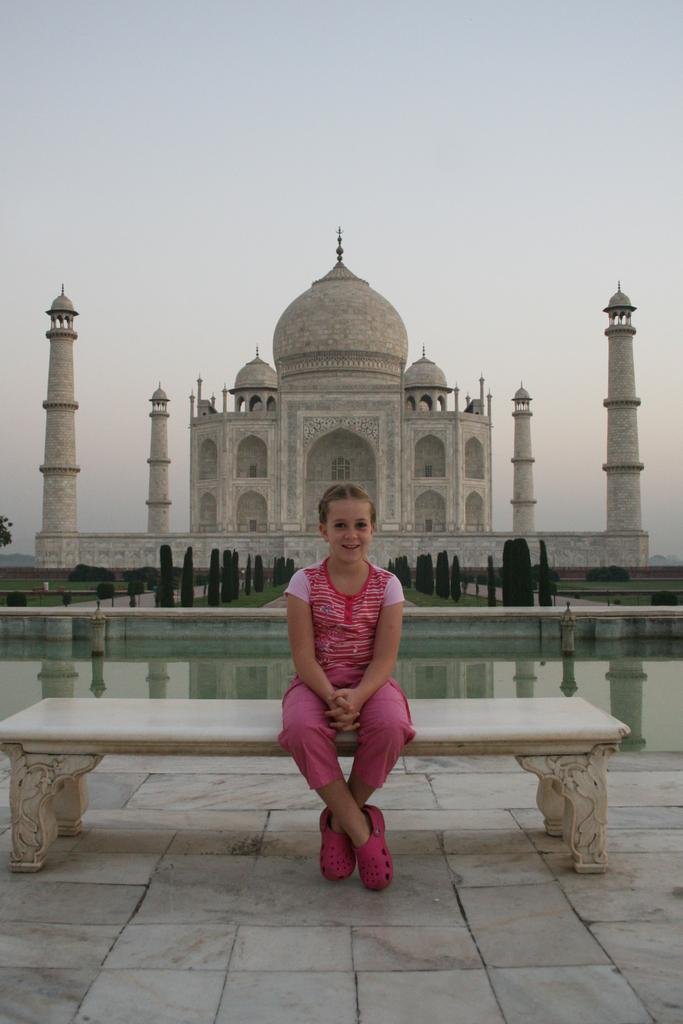Who is the main subject in the image? There is a girl in the image. What is the girl wearing? The girl is wearing a pink dress. Where is the girl sitting? The girl is sitting on a bench. What can be seen in the background of the image? There is water, trees, and the Taj Mahal visible in the image. What part of the natural environment is visible in the image? The sky is visible in the image. What type of sign can be seen in the image? There is no sign present in the image. What do the snails in the image find interesting? There are no snails present in the image. 